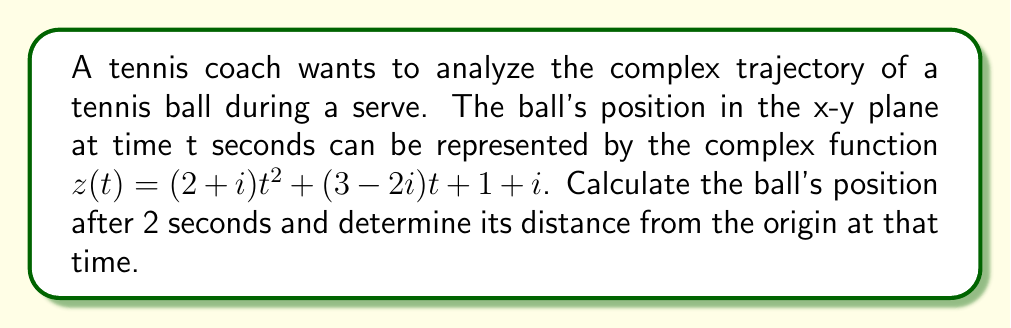Could you help me with this problem? To solve this problem, we'll follow these steps:

1) First, we need to calculate $z(2)$ by substituting $t=2$ into the given function:

   $z(2) = (2+i)(2)^2 + (3-2i)(2) + (1+i)$

2) Let's simplify each term:
   
   $(2+i)(2)^2 = (2+i)(4) = 8+4i$
   $(3-2i)(2) = 6-4i$
   $1+i$ remains as is

3) Now, we can add these terms:

   $z(2) = (8+4i) + (6-4i) + (1+i)$
   $z(2) = 15+i$

4) So, after 2 seconds, the ball's position is represented by the complex number $15+i$.

5) To find the distance from the origin, we need to calculate the magnitude of this complex number:

   $|z(2)| = \sqrt{(15)^2 + (1)^2} = \sqrt{226}$

6) The distance from the origin is therefore $\sqrt{226}$ units.
Answer: $15+i$; $\sqrt{226}$ units 